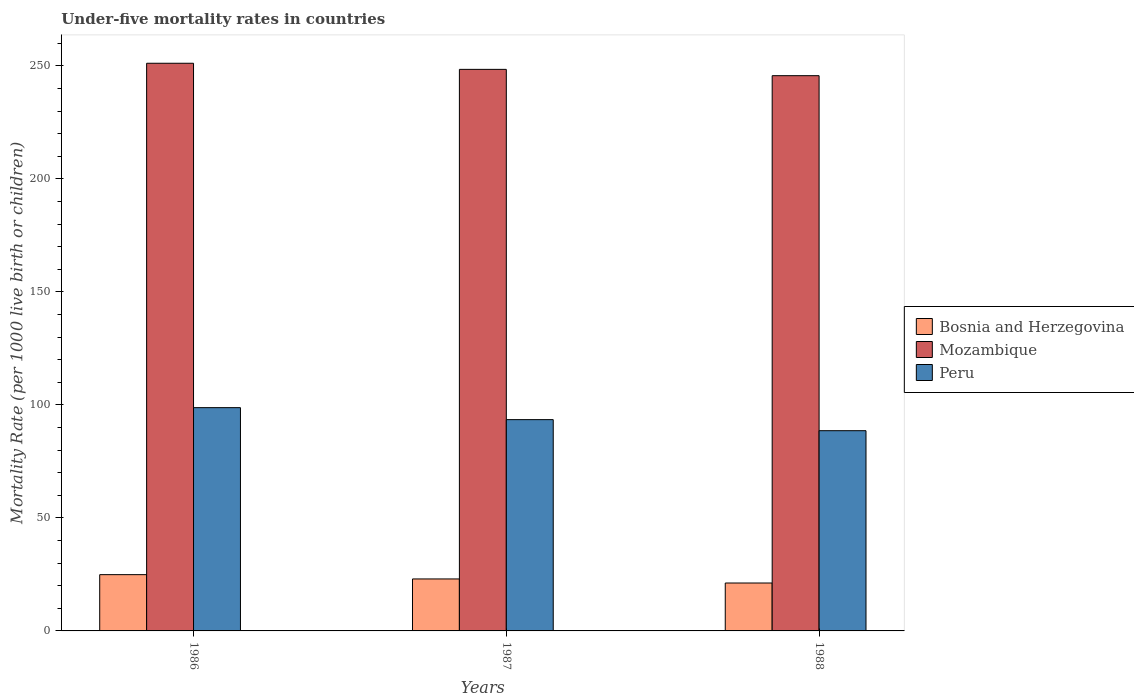How many different coloured bars are there?
Your response must be concise. 3. How many groups of bars are there?
Offer a terse response. 3. Are the number of bars on each tick of the X-axis equal?
Provide a succinct answer. Yes. In how many cases, is the number of bars for a given year not equal to the number of legend labels?
Make the answer very short. 0. What is the under-five mortality rate in Mozambique in 1987?
Give a very brief answer. 248.5. Across all years, what is the maximum under-five mortality rate in Peru?
Offer a terse response. 98.8. Across all years, what is the minimum under-five mortality rate in Bosnia and Herzegovina?
Offer a terse response. 21.2. In which year was the under-five mortality rate in Peru maximum?
Your answer should be compact. 1986. What is the total under-five mortality rate in Mozambique in the graph?
Your answer should be very brief. 745.4. What is the difference between the under-five mortality rate in Peru in 1986 and that in 1987?
Your answer should be very brief. 5.3. What is the difference between the under-five mortality rate in Peru in 1986 and the under-five mortality rate in Bosnia and Herzegovina in 1987?
Ensure brevity in your answer.  75.8. What is the average under-five mortality rate in Peru per year?
Offer a very short reply. 93.63. In the year 1987, what is the difference between the under-five mortality rate in Peru and under-five mortality rate in Bosnia and Herzegovina?
Provide a succinct answer. 70.5. What is the ratio of the under-five mortality rate in Peru in 1987 to that in 1988?
Make the answer very short. 1.06. What is the difference between the highest and the second highest under-five mortality rate in Mozambique?
Give a very brief answer. 2.7. What is the difference between the highest and the lowest under-five mortality rate in Peru?
Offer a terse response. 10.2. What does the 2nd bar from the left in 1987 represents?
Give a very brief answer. Mozambique. How many bars are there?
Your response must be concise. 9. Are all the bars in the graph horizontal?
Your answer should be very brief. No. How many years are there in the graph?
Provide a succinct answer. 3. What is the difference between two consecutive major ticks on the Y-axis?
Offer a terse response. 50. Are the values on the major ticks of Y-axis written in scientific E-notation?
Offer a very short reply. No. Does the graph contain any zero values?
Ensure brevity in your answer.  No. Does the graph contain grids?
Provide a succinct answer. No. Where does the legend appear in the graph?
Keep it short and to the point. Center right. How many legend labels are there?
Your answer should be compact. 3. How are the legend labels stacked?
Keep it short and to the point. Vertical. What is the title of the graph?
Offer a very short reply. Under-five mortality rates in countries. What is the label or title of the X-axis?
Provide a short and direct response. Years. What is the label or title of the Y-axis?
Keep it short and to the point. Mortality Rate (per 1000 live birth or children). What is the Mortality Rate (per 1000 live birth or children) in Bosnia and Herzegovina in 1986?
Your answer should be compact. 24.9. What is the Mortality Rate (per 1000 live birth or children) of Mozambique in 1986?
Offer a terse response. 251.2. What is the Mortality Rate (per 1000 live birth or children) of Peru in 1986?
Your response must be concise. 98.8. What is the Mortality Rate (per 1000 live birth or children) in Mozambique in 1987?
Provide a succinct answer. 248.5. What is the Mortality Rate (per 1000 live birth or children) of Peru in 1987?
Ensure brevity in your answer.  93.5. What is the Mortality Rate (per 1000 live birth or children) of Bosnia and Herzegovina in 1988?
Keep it short and to the point. 21.2. What is the Mortality Rate (per 1000 live birth or children) of Mozambique in 1988?
Your answer should be compact. 245.7. What is the Mortality Rate (per 1000 live birth or children) of Peru in 1988?
Keep it short and to the point. 88.6. Across all years, what is the maximum Mortality Rate (per 1000 live birth or children) in Bosnia and Herzegovina?
Offer a terse response. 24.9. Across all years, what is the maximum Mortality Rate (per 1000 live birth or children) in Mozambique?
Your answer should be compact. 251.2. Across all years, what is the maximum Mortality Rate (per 1000 live birth or children) in Peru?
Your answer should be compact. 98.8. Across all years, what is the minimum Mortality Rate (per 1000 live birth or children) in Bosnia and Herzegovina?
Keep it short and to the point. 21.2. Across all years, what is the minimum Mortality Rate (per 1000 live birth or children) in Mozambique?
Give a very brief answer. 245.7. Across all years, what is the minimum Mortality Rate (per 1000 live birth or children) in Peru?
Keep it short and to the point. 88.6. What is the total Mortality Rate (per 1000 live birth or children) in Bosnia and Herzegovina in the graph?
Your answer should be compact. 69.1. What is the total Mortality Rate (per 1000 live birth or children) of Mozambique in the graph?
Ensure brevity in your answer.  745.4. What is the total Mortality Rate (per 1000 live birth or children) in Peru in the graph?
Provide a short and direct response. 280.9. What is the difference between the Mortality Rate (per 1000 live birth or children) in Mozambique in 1986 and that in 1987?
Your answer should be compact. 2.7. What is the difference between the Mortality Rate (per 1000 live birth or children) in Peru in 1986 and that in 1987?
Your answer should be very brief. 5.3. What is the difference between the Mortality Rate (per 1000 live birth or children) in Bosnia and Herzegovina in 1986 and that in 1988?
Offer a very short reply. 3.7. What is the difference between the Mortality Rate (per 1000 live birth or children) in Peru in 1986 and that in 1988?
Make the answer very short. 10.2. What is the difference between the Mortality Rate (per 1000 live birth or children) in Bosnia and Herzegovina in 1986 and the Mortality Rate (per 1000 live birth or children) in Mozambique in 1987?
Your answer should be compact. -223.6. What is the difference between the Mortality Rate (per 1000 live birth or children) in Bosnia and Herzegovina in 1986 and the Mortality Rate (per 1000 live birth or children) in Peru in 1987?
Provide a short and direct response. -68.6. What is the difference between the Mortality Rate (per 1000 live birth or children) of Mozambique in 1986 and the Mortality Rate (per 1000 live birth or children) of Peru in 1987?
Your answer should be compact. 157.7. What is the difference between the Mortality Rate (per 1000 live birth or children) in Bosnia and Herzegovina in 1986 and the Mortality Rate (per 1000 live birth or children) in Mozambique in 1988?
Your response must be concise. -220.8. What is the difference between the Mortality Rate (per 1000 live birth or children) of Bosnia and Herzegovina in 1986 and the Mortality Rate (per 1000 live birth or children) of Peru in 1988?
Offer a terse response. -63.7. What is the difference between the Mortality Rate (per 1000 live birth or children) of Mozambique in 1986 and the Mortality Rate (per 1000 live birth or children) of Peru in 1988?
Give a very brief answer. 162.6. What is the difference between the Mortality Rate (per 1000 live birth or children) of Bosnia and Herzegovina in 1987 and the Mortality Rate (per 1000 live birth or children) of Mozambique in 1988?
Provide a succinct answer. -222.7. What is the difference between the Mortality Rate (per 1000 live birth or children) in Bosnia and Herzegovina in 1987 and the Mortality Rate (per 1000 live birth or children) in Peru in 1988?
Provide a succinct answer. -65.6. What is the difference between the Mortality Rate (per 1000 live birth or children) of Mozambique in 1987 and the Mortality Rate (per 1000 live birth or children) of Peru in 1988?
Your response must be concise. 159.9. What is the average Mortality Rate (per 1000 live birth or children) of Bosnia and Herzegovina per year?
Keep it short and to the point. 23.03. What is the average Mortality Rate (per 1000 live birth or children) of Mozambique per year?
Give a very brief answer. 248.47. What is the average Mortality Rate (per 1000 live birth or children) in Peru per year?
Provide a succinct answer. 93.63. In the year 1986, what is the difference between the Mortality Rate (per 1000 live birth or children) in Bosnia and Herzegovina and Mortality Rate (per 1000 live birth or children) in Mozambique?
Your answer should be very brief. -226.3. In the year 1986, what is the difference between the Mortality Rate (per 1000 live birth or children) in Bosnia and Herzegovina and Mortality Rate (per 1000 live birth or children) in Peru?
Your answer should be compact. -73.9. In the year 1986, what is the difference between the Mortality Rate (per 1000 live birth or children) of Mozambique and Mortality Rate (per 1000 live birth or children) of Peru?
Keep it short and to the point. 152.4. In the year 1987, what is the difference between the Mortality Rate (per 1000 live birth or children) of Bosnia and Herzegovina and Mortality Rate (per 1000 live birth or children) of Mozambique?
Provide a short and direct response. -225.5. In the year 1987, what is the difference between the Mortality Rate (per 1000 live birth or children) in Bosnia and Herzegovina and Mortality Rate (per 1000 live birth or children) in Peru?
Your answer should be very brief. -70.5. In the year 1987, what is the difference between the Mortality Rate (per 1000 live birth or children) in Mozambique and Mortality Rate (per 1000 live birth or children) in Peru?
Give a very brief answer. 155. In the year 1988, what is the difference between the Mortality Rate (per 1000 live birth or children) in Bosnia and Herzegovina and Mortality Rate (per 1000 live birth or children) in Mozambique?
Provide a short and direct response. -224.5. In the year 1988, what is the difference between the Mortality Rate (per 1000 live birth or children) of Bosnia and Herzegovina and Mortality Rate (per 1000 live birth or children) of Peru?
Provide a succinct answer. -67.4. In the year 1988, what is the difference between the Mortality Rate (per 1000 live birth or children) in Mozambique and Mortality Rate (per 1000 live birth or children) in Peru?
Your answer should be very brief. 157.1. What is the ratio of the Mortality Rate (per 1000 live birth or children) in Bosnia and Herzegovina in 1986 to that in 1987?
Keep it short and to the point. 1.08. What is the ratio of the Mortality Rate (per 1000 live birth or children) of Mozambique in 1986 to that in 1987?
Your answer should be compact. 1.01. What is the ratio of the Mortality Rate (per 1000 live birth or children) in Peru in 1986 to that in 1987?
Give a very brief answer. 1.06. What is the ratio of the Mortality Rate (per 1000 live birth or children) in Bosnia and Herzegovina in 1986 to that in 1988?
Provide a succinct answer. 1.17. What is the ratio of the Mortality Rate (per 1000 live birth or children) of Mozambique in 1986 to that in 1988?
Ensure brevity in your answer.  1.02. What is the ratio of the Mortality Rate (per 1000 live birth or children) of Peru in 1986 to that in 1988?
Offer a very short reply. 1.12. What is the ratio of the Mortality Rate (per 1000 live birth or children) of Bosnia and Herzegovina in 1987 to that in 1988?
Make the answer very short. 1.08. What is the ratio of the Mortality Rate (per 1000 live birth or children) in Mozambique in 1987 to that in 1988?
Provide a short and direct response. 1.01. What is the ratio of the Mortality Rate (per 1000 live birth or children) in Peru in 1987 to that in 1988?
Make the answer very short. 1.06. What is the difference between the highest and the second highest Mortality Rate (per 1000 live birth or children) in Peru?
Your answer should be very brief. 5.3. What is the difference between the highest and the lowest Mortality Rate (per 1000 live birth or children) in Peru?
Ensure brevity in your answer.  10.2. 